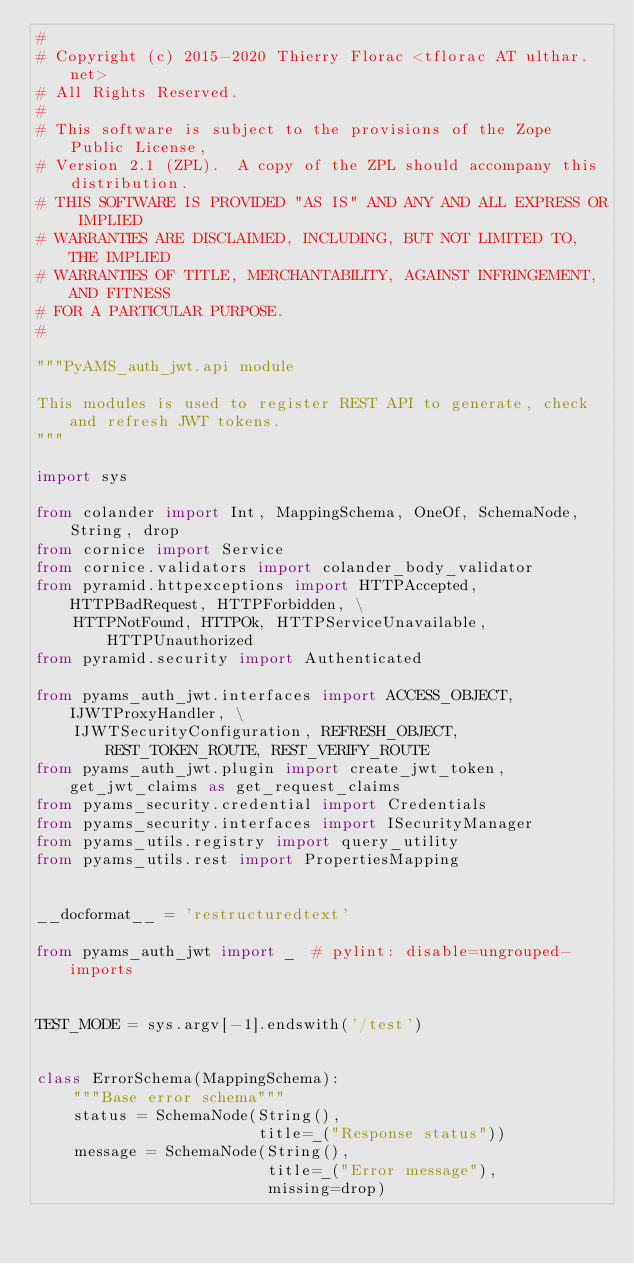Convert code to text. <code><loc_0><loc_0><loc_500><loc_500><_Python_>#
# Copyright (c) 2015-2020 Thierry Florac <tflorac AT ulthar.net>
# All Rights Reserved.
#
# This software is subject to the provisions of the Zope Public License,
# Version 2.1 (ZPL).  A copy of the ZPL should accompany this distribution.
# THIS SOFTWARE IS PROVIDED "AS IS" AND ANY AND ALL EXPRESS OR IMPLIED
# WARRANTIES ARE DISCLAIMED, INCLUDING, BUT NOT LIMITED TO, THE IMPLIED
# WARRANTIES OF TITLE, MERCHANTABILITY, AGAINST INFRINGEMENT, AND FITNESS
# FOR A PARTICULAR PURPOSE.
#

"""PyAMS_auth_jwt.api module

This modules is used to register REST API to generate, check and refresh JWT tokens.
"""

import sys

from colander import Int, MappingSchema, OneOf, SchemaNode, String, drop
from cornice import Service
from cornice.validators import colander_body_validator
from pyramid.httpexceptions import HTTPAccepted, HTTPBadRequest, HTTPForbidden, \
    HTTPNotFound, HTTPOk, HTTPServiceUnavailable, HTTPUnauthorized
from pyramid.security import Authenticated

from pyams_auth_jwt.interfaces import ACCESS_OBJECT, IJWTProxyHandler, \
    IJWTSecurityConfiguration, REFRESH_OBJECT, REST_TOKEN_ROUTE, REST_VERIFY_ROUTE
from pyams_auth_jwt.plugin import create_jwt_token, get_jwt_claims as get_request_claims
from pyams_security.credential import Credentials
from pyams_security.interfaces import ISecurityManager
from pyams_utils.registry import query_utility
from pyams_utils.rest import PropertiesMapping


__docformat__ = 'restructuredtext'

from pyams_auth_jwt import _  # pylint: disable=ungrouped-imports


TEST_MODE = sys.argv[-1].endswith('/test')


class ErrorSchema(MappingSchema):
    """Base error schema"""
    status = SchemaNode(String(),
                        title=_("Response status"))
    message = SchemaNode(String(),
                         title=_("Error message"),
                         missing=drop)

</code> 